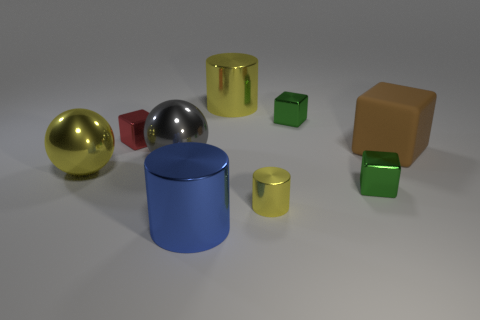Is there another cylinder of the same color as the tiny cylinder?
Offer a very short reply. Yes. What is the material of the large yellow ball?
Ensure brevity in your answer.  Metal. What is the size of the gray shiny thing on the left side of the blue shiny cylinder?
Your response must be concise. Large. What number of large yellow objects are the same shape as the big gray metallic thing?
Your answer should be compact. 1. The blue thing that is the same material as the tiny cylinder is what shape?
Ensure brevity in your answer.  Cylinder. What number of yellow objects are metal objects or large things?
Your response must be concise. 3. There is a big brown rubber object; are there any small green objects to the left of it?
Provide a succinct answer. Yes. Do the tiny metallic thing left of the gray metallic sphere and the big yellow metallic thing that is on the left side of the big blue cylinder have the same shape?
Keep it short and to the point. No. What is the material of the brown object that is the same shape as the red metal thing?
Give a very brief answer. Rubber. How many cylinders are big blue metallic objects or tiny gray objects?
Provide a short and direct response. 1. 